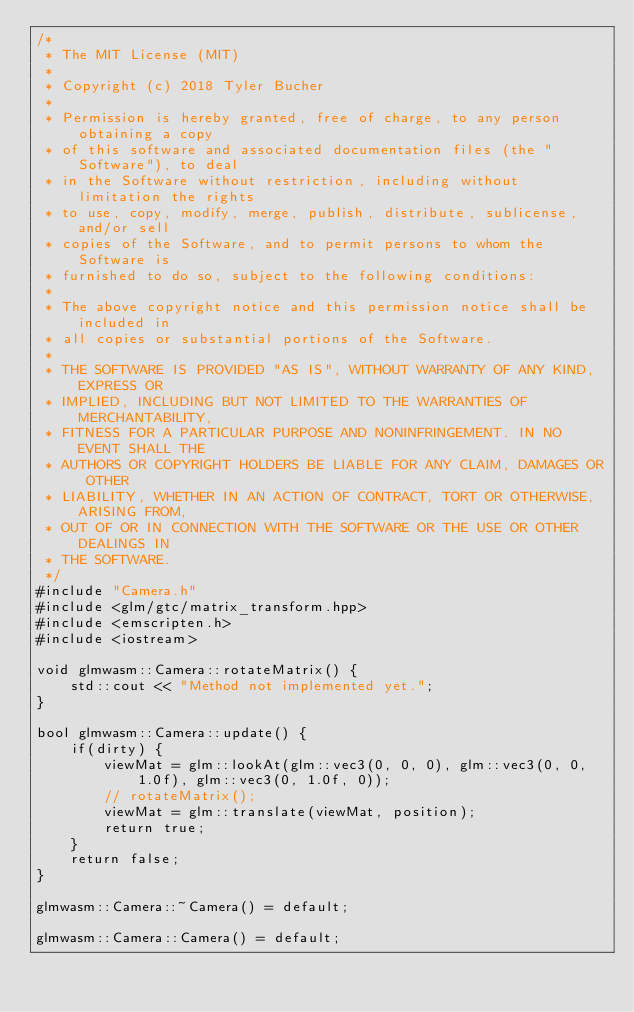<code> <loc_0><loc_0><loc_500><loc_500><_C++_>/*
 * The MIT License (MIT)
 *
 * Copyright (c) 2018 Tyler Bucher
 *
 * Permission is hereby granted, free of charge, to any person obtaining a copy
 * of this software and associated documentation files (the "Software"), to deal
 * in the Software without restriction, including without limitation the rights
 * to use, copy, modify, merge, publish, distribute, sublicense, and/or sell
 * copies of the Software, and to permit persons to whom the Software is
 * furnished to do so, subject to the following conditions:
 *
 * The above copyright notice and this permission notice shall be included in
 * all copies or substantial portions of the Software.
 *
 * THE SOFTWARE IS PROVIDED "AS IS", WITHOUT WARRANTY OF ANY KIND, EXPRESS OR
 * IMPLIED, INCLUDING BUT NOT LIMITED TO THE WARRANTIES OF MERCHANTABILITY,
 * FITNESS FOR A PARTICULAR PURPOSE AND NONINFRINGEMENT. IN NO EVENT SHALL THE
 * AUTHORS OR COPYRIGHT HOLDERS BE LIABLE FOR ANY CLAIM, DAMAGES OR OTHER
 * LIABILITY, WHETHER IN AN ACTION OF CONTRACT, TORT OR OTHERWISE, ARISING FROM,
 * OUT OF OR IN CONNECTION WITH THE SOFTWARE OR THE USE OR OTHER DEALINGS IN
 * THE SOFTWARE.
 */
#include "Camera.h"
#include <glm/gtc/matrix_transform.hpp>
#include <emscripten.h>
#include <iostream>

void glmwasm::Camera::rotateMatrix() {
    std::cout << "Method not implemented yet.";
}

bool glmwasm::Camera::update() {
    if(dirty) {
        viewMat = glm::lookAt(glm::vec3(0, 0, 0), glm::vec3(0, 0, 1.0f), glm::vec3(0, 1.0f, 0));
        // rotateMatrix();
        viewMat = glm::translate(viewMat, position);
        return true;
    }
    return false;
}

glmwasm::Camera::~Camera() = default;

glmwasm::Camera::Camera() = default;
</code> 